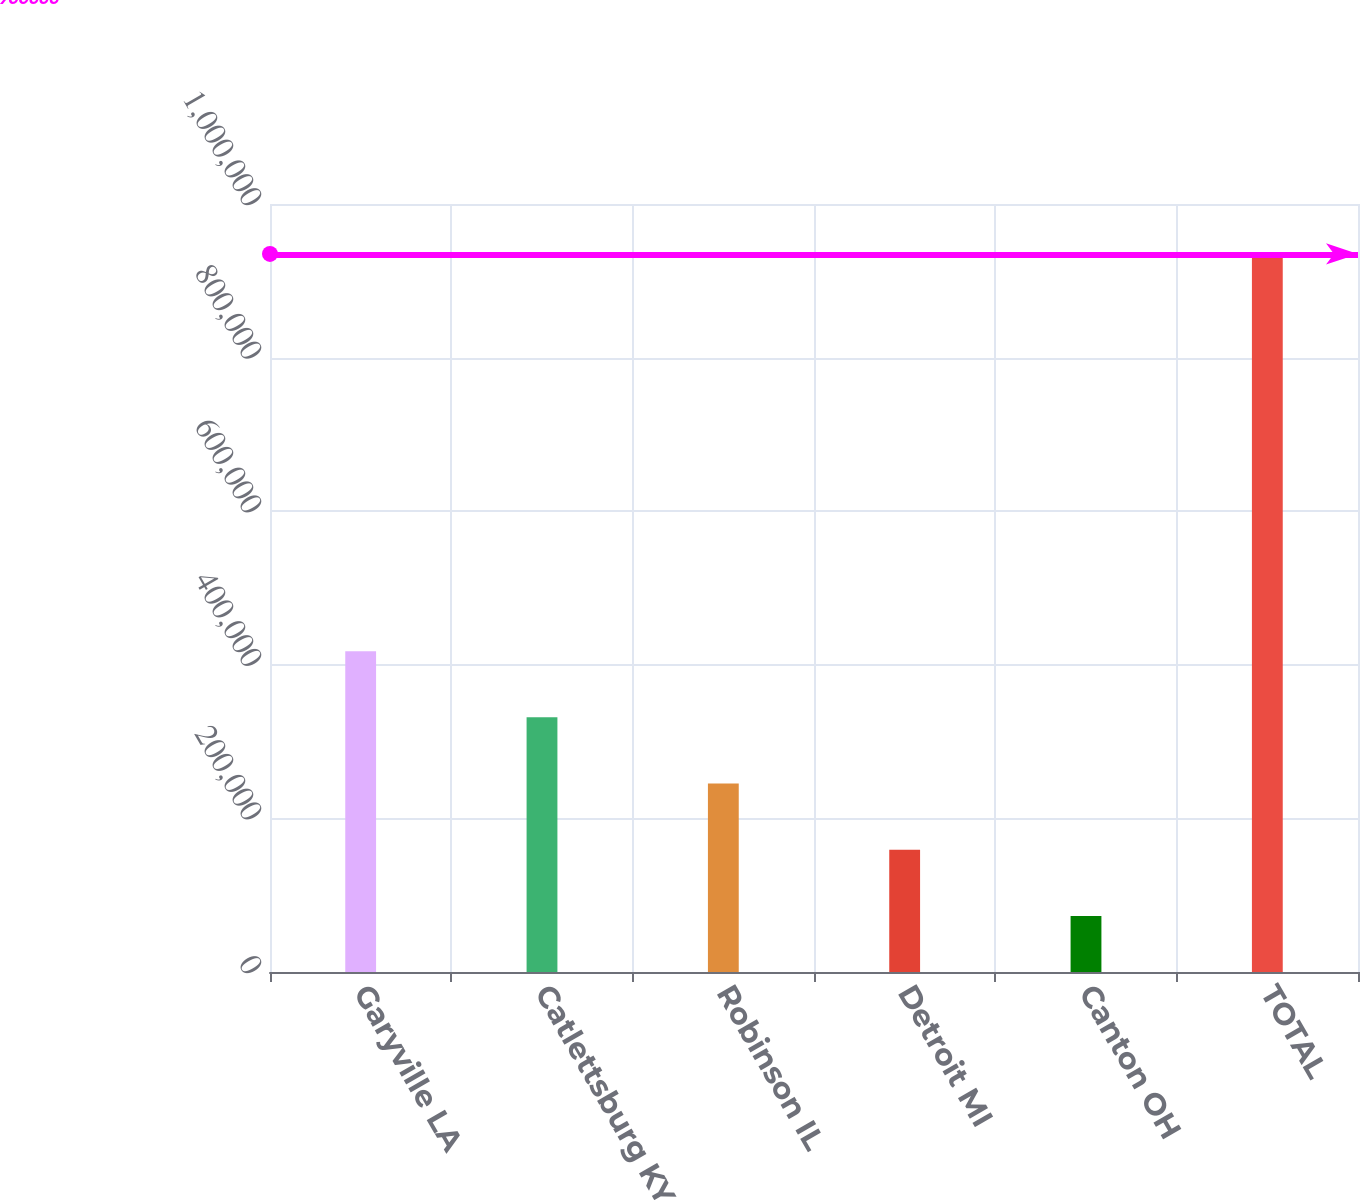Convert chart. <chart><loc_0><loc_0><loc_500><loc_500><bar_chart><fcel>Garyville LA<fcel>Catlettsburg KY<fcel>Robinson IL<fcel>Detroit MI<fcel>Canton OH<fcel>TOTAL<nl><fcel>417800<fcel>331600<fcel>245400<fcel>159200<fcel>73000<fcel>935000<nl></chart> 